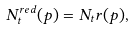Convert formula to latex. <formula><loc_0><loc_0><loc_500><loc_500>N _ { t } ^ { r e d } ( p ) = N _ { t } r ( p ) ,</formula> 